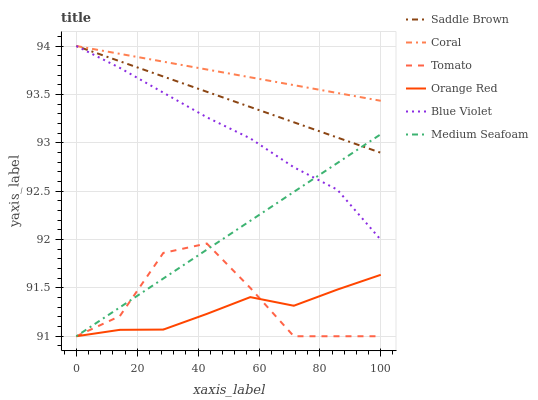Does Orange Red have the minimum area under the curve?
Answer yes or no. Yes. Does Coral have the maximum area under the curve?
Answer yes or no. Yes. Does Coral have the minimum area under the curve?
Answer yes or no. No. Does Orange Red have the maximum area under the curve?
Answer yes or no. No. Is Medium Seafoam the smoothest?
Answer yes or no. Yes. Is Tomato the roughest?
Answer yes or no. Yes. Is Coral the smoothest?
Answer yes or no. No. Is Coral the roughest?
Answer yes or no. No. Does Coral have the lowest value?
Answer yes or no. No. Does Orange Red have the highest value?
Answer yes or no. No. Is Orange Red less than Blue Violet?
Answer yes or no. Yes. Is Coral greater than Orange Red?
Answer yes or no. Yes. Does Orange Red intersect Blue Violet?
Answer yes or no. No. 